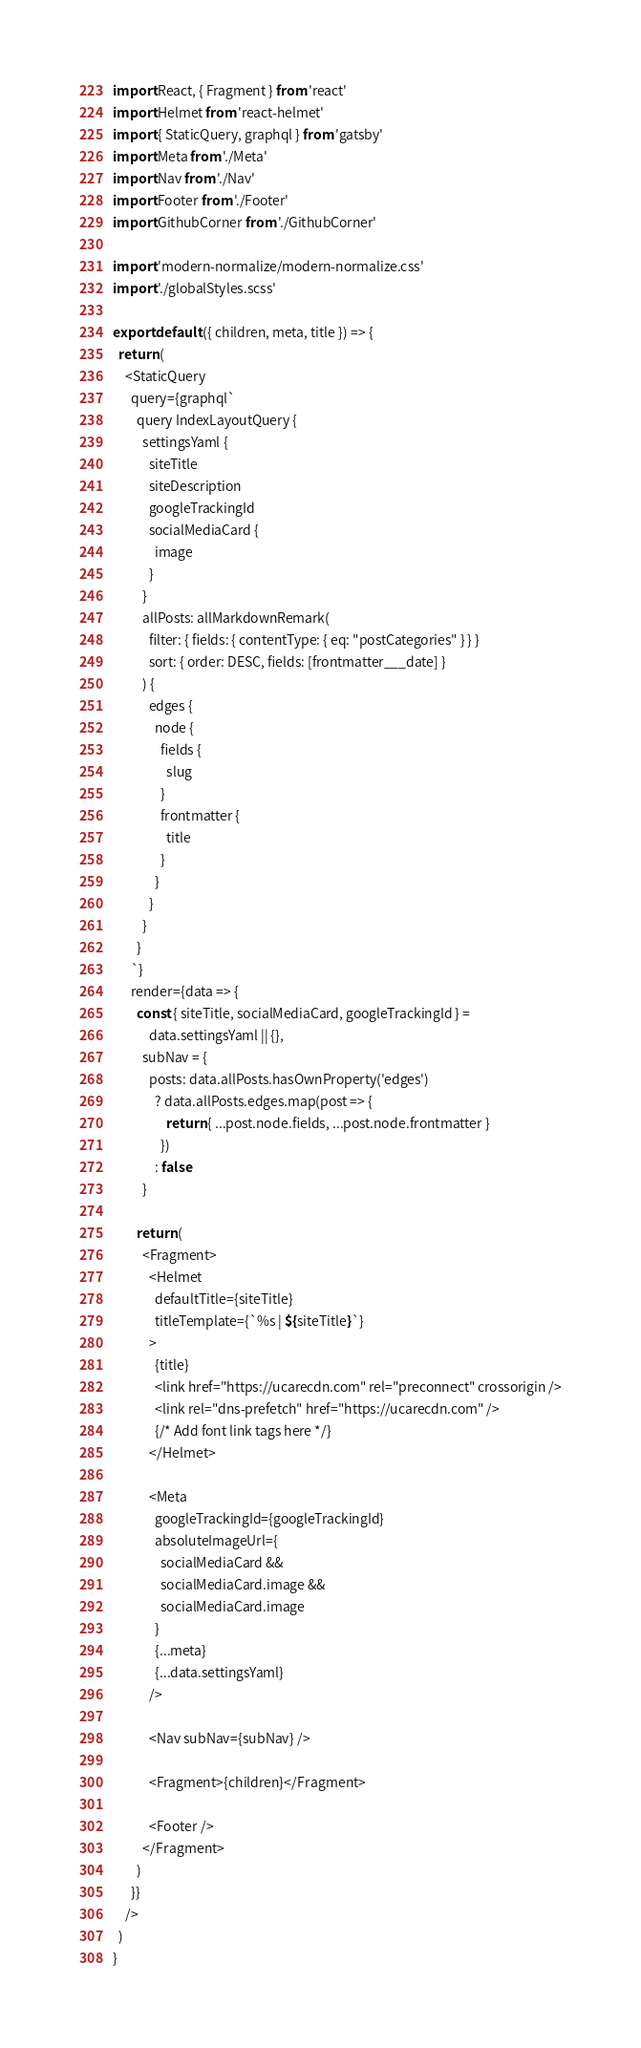<code> <loc_0><loc_0><loc_500><loc_500><_JavaScript_>import React, { Fragment } from 'react'
import Helmet from 'react-helmet'
import { StaticQuery, graphql } from 'gatsby'
import Meta from './Meta'
import Nav from './Nav'
import Footer from './Footer'
import GithubCorner from './GithubCorner'

import 'modern-normalize/modern-normalize.css'
import './globalStyles.scss'

export default ({ children, meta, title }) => {
  return (
    <StaticQuery
      query={graphql`
        query IndexLayoutQuery {
          settingsYaml {
            siteTitle
            siteDescription
            googleTrackingId
            socialMediaCard {
              image
            }
          }
          allPosts: allMarkdownRemark(
            filter: { fields: { contentType: { eq: "postCategories" } } }
            sort: { order: DESC, fields: [frontmatter___date] }
          ) {
            edges {
              node {
                fields {
                  slug
                }
                frontmatter {
                  title
                }
              }
            }
          }
        }
      `}
      render={data => {
        const { siteTitle, socialMediaCard, googleTrackingId } =
            data.settingsYaml || {},
          subNav = {
            posts: data.allPosts.hasOwnProperty('edges')
              ? data.allPosts.edges.map(post => {
                  return { ...post.node.fields, ...post.node.frontmatter }
                })
              : false
          }

        return (
          <Fragment>
            <Helmet
              defaultTitle={siteTitle}
              titleTemplate={`%s | ${siteTitle}`}
            >
              {title}
              <link href="https://ucarecdn.com" rel="preconnect" crossorigin />
              <link rel="dns-prefetch" href="https://ucarecdn.com" />
              {/* Add font link tags here */}
            </Helmet>

            <Meta
              googleTrackingId={googleTrackingId}
              absoluteImageUrl={
                socialMediaCard &&
                socialMediaCard.image &&
                socialMediaCard.image
              }
              {...meta}
              {...data.settingsYaml}
            />

            <Nav subNav={subNav} />

            <Fragment>{children}</Fragment>

            <Footer />
          </Fragment>
        )
      }}
    />
  )
}
</code> 